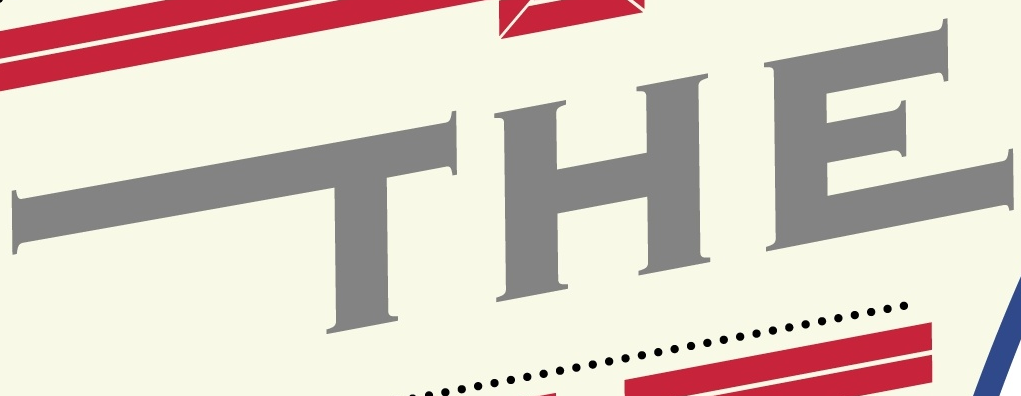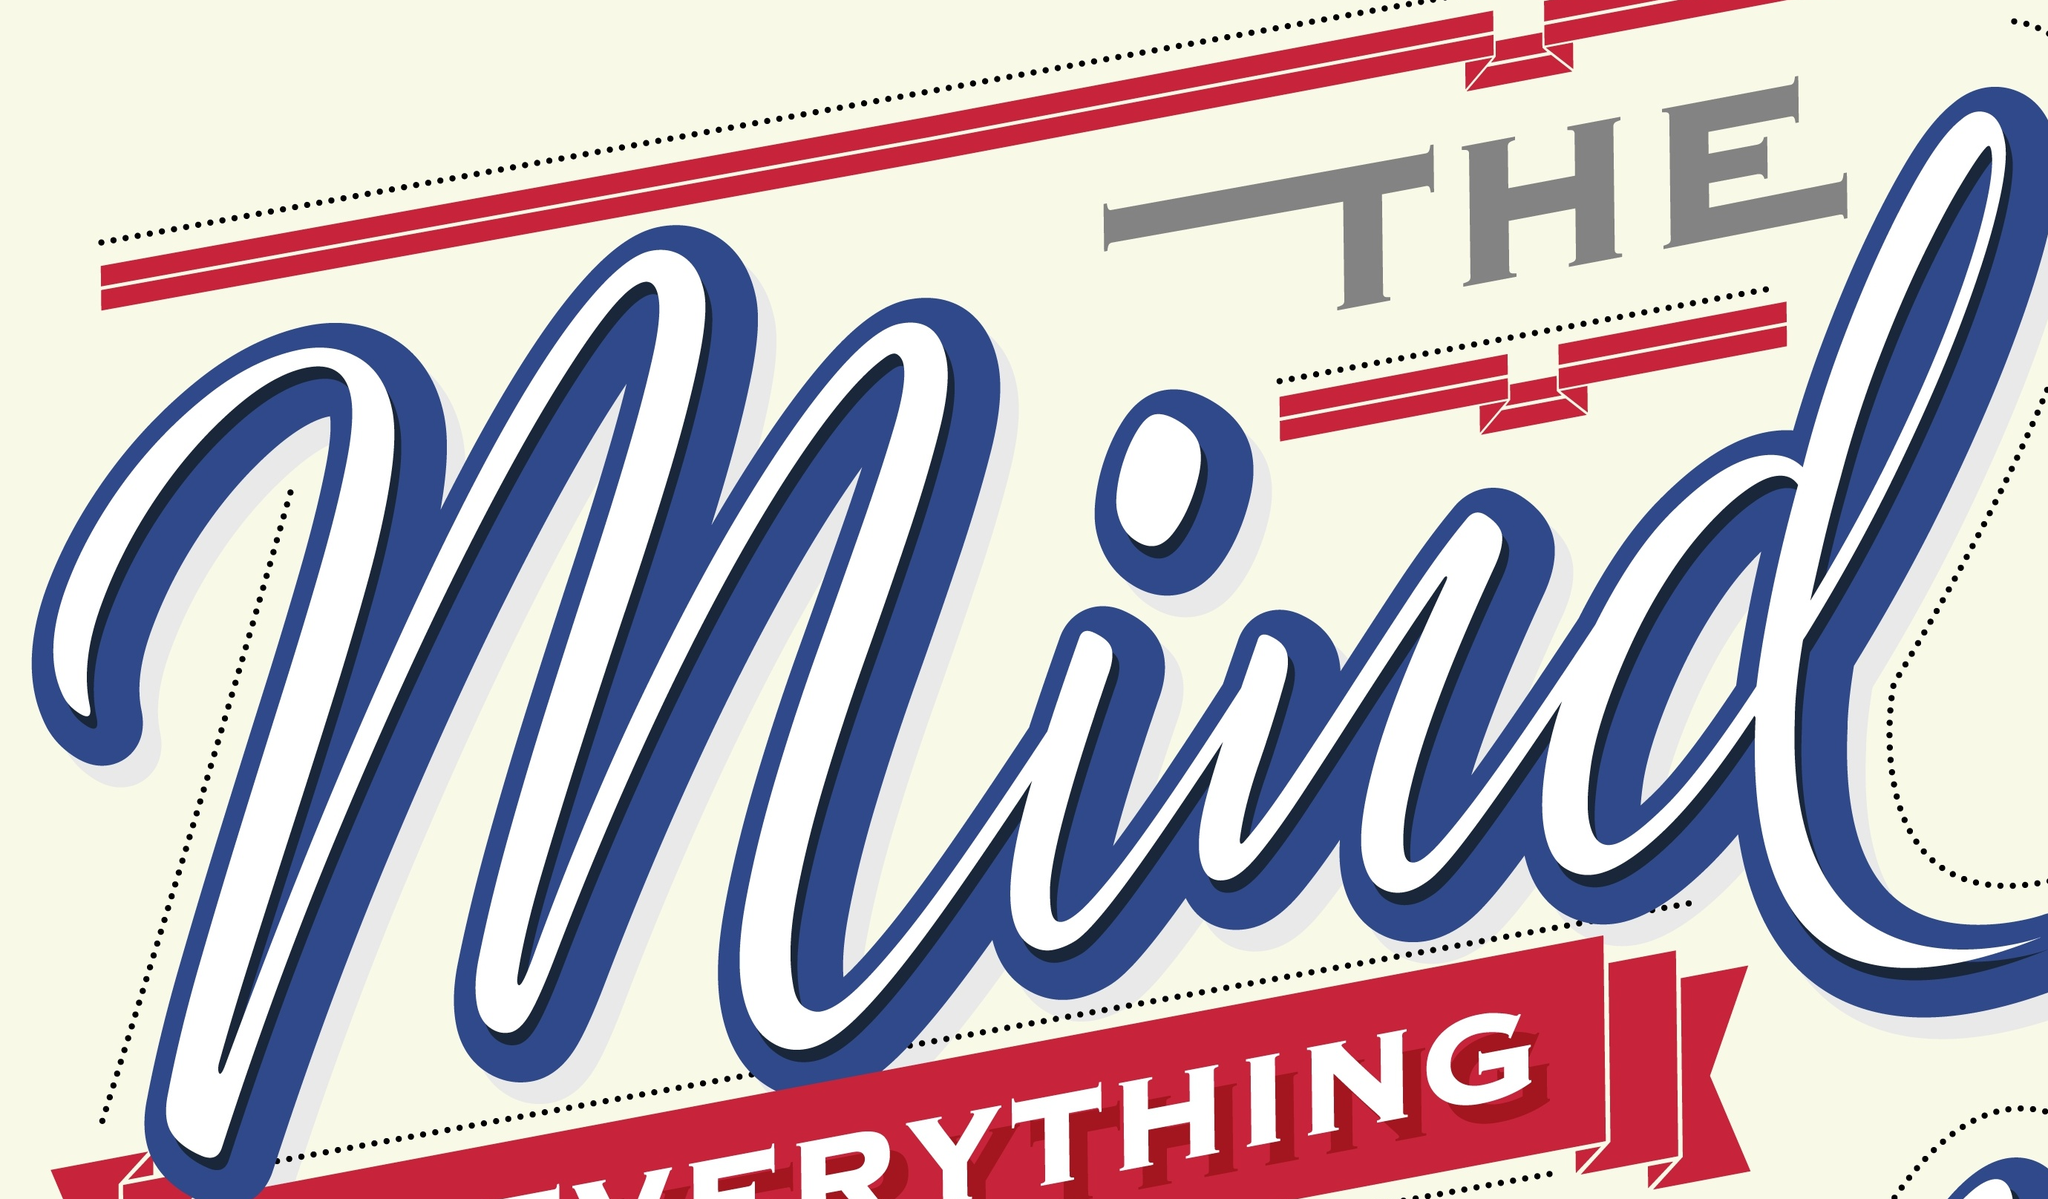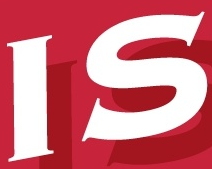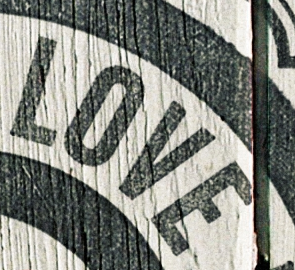What words can you see in these images in sequence, separated by a semicolon? THE; Mind; IS; LOVE 